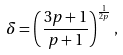<formula> <loc_0><loc_0><loc_500><loc_500>\delta = \left ( \frac { 3 p + 1 } { p + 1 } \right ) ^ { \frac { 1 } { 2 p } } ,</formula> 